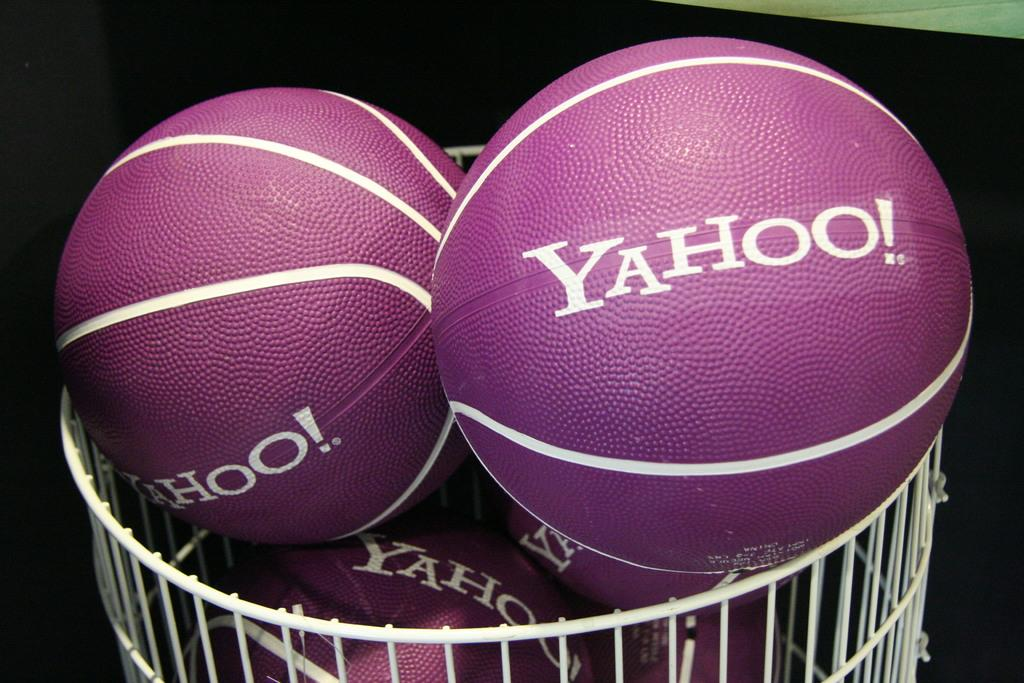Where was the image taken? The image was taken indoors. What can be observed about the lighting in the image? The background of the image is dark. What is the main object in the middle of the image? There is a basket in the middle of the image. What is inside the basket? There are a few balls in the basket. Where is the nest located in the image? There is no nest present in the image. How does the swing move in the image? There is no swing present in the image. 